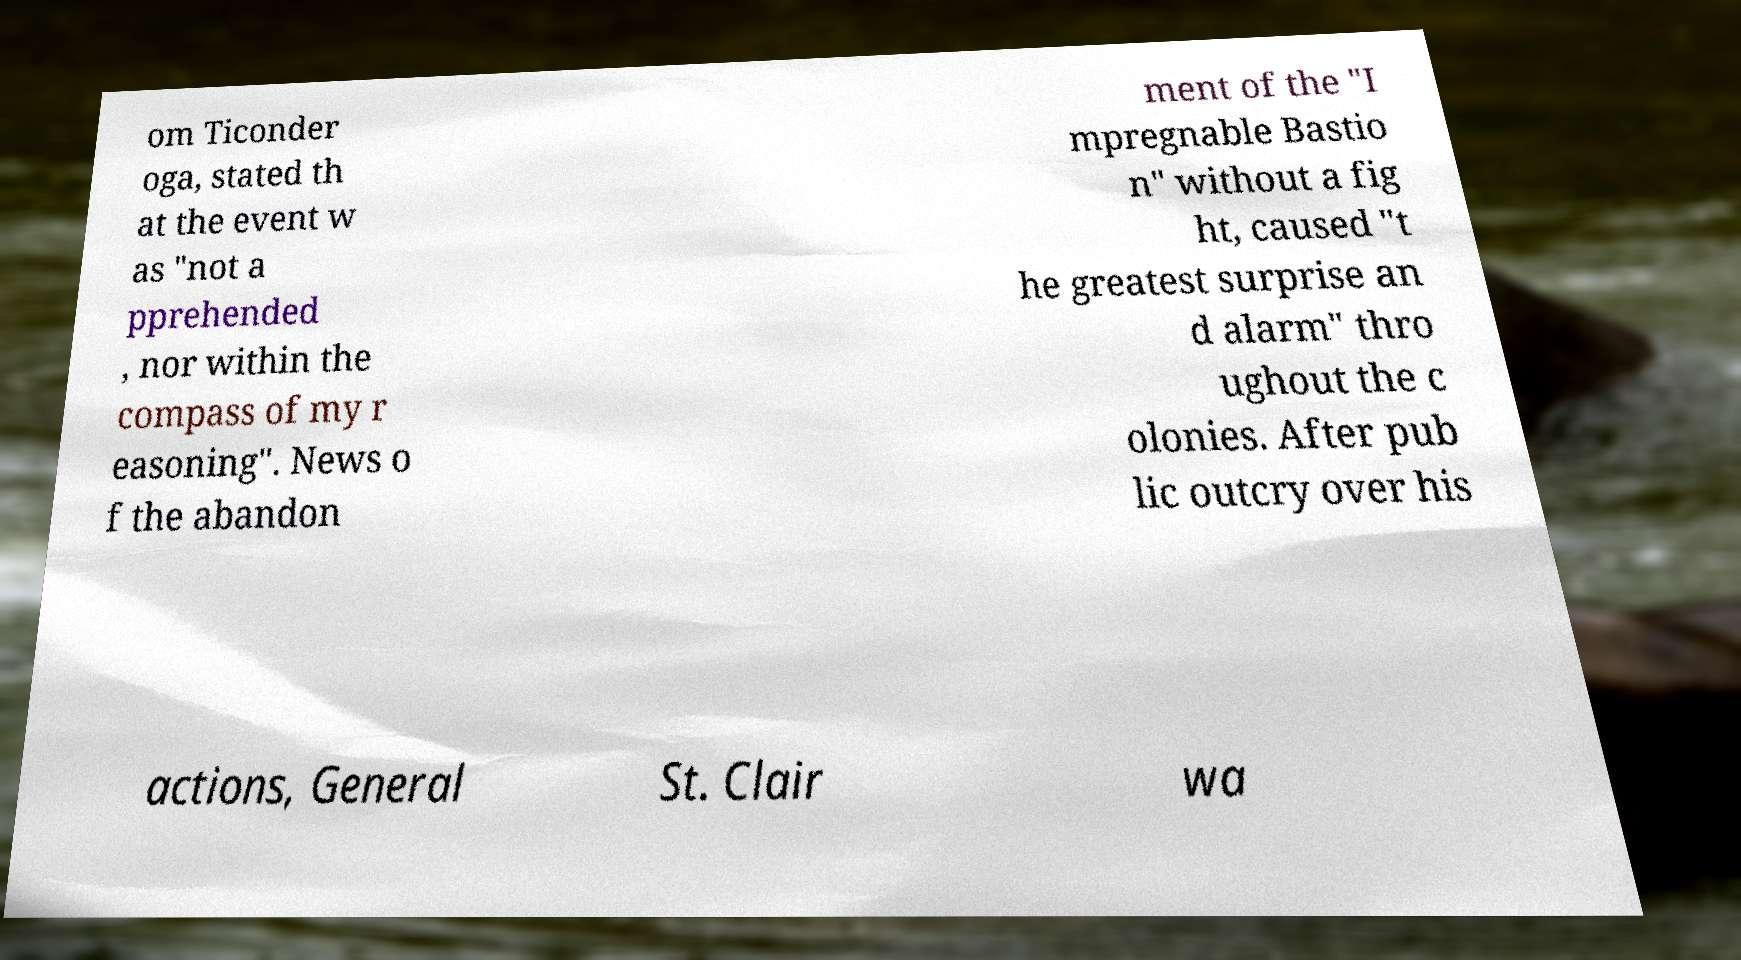What messages or text are displayed in this image? I need them in a readable, typed format. om Ticonder oga, stated th at the event w as "not a pprehended , nor within the compass of my r easoning". News o f the abandon ment of the "I mpregnable Bastio n" without a fig ht, caused "t he greatest surprise an d alarm" thro ughout the c olonies. After pub lic outcry over his actions, General St. Clair wa 